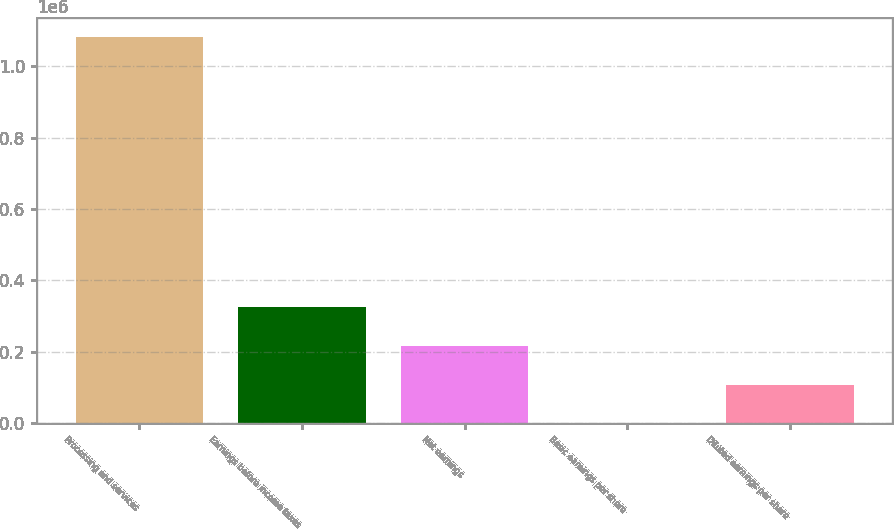Convert chart. <chart><loc_0><loc_0><loc_500><loc_500><bar_chart><fcel>Processing and services<fcel>Earnings before income taxes<fcel>Net earnings<fcel>Basic earnings per share<fcel>Diluted earnings per share<nl><fcel>1.08065e+06<fcel>324196<fcel>216131<fcel>0.41<fcel>108065<nl></chart> 